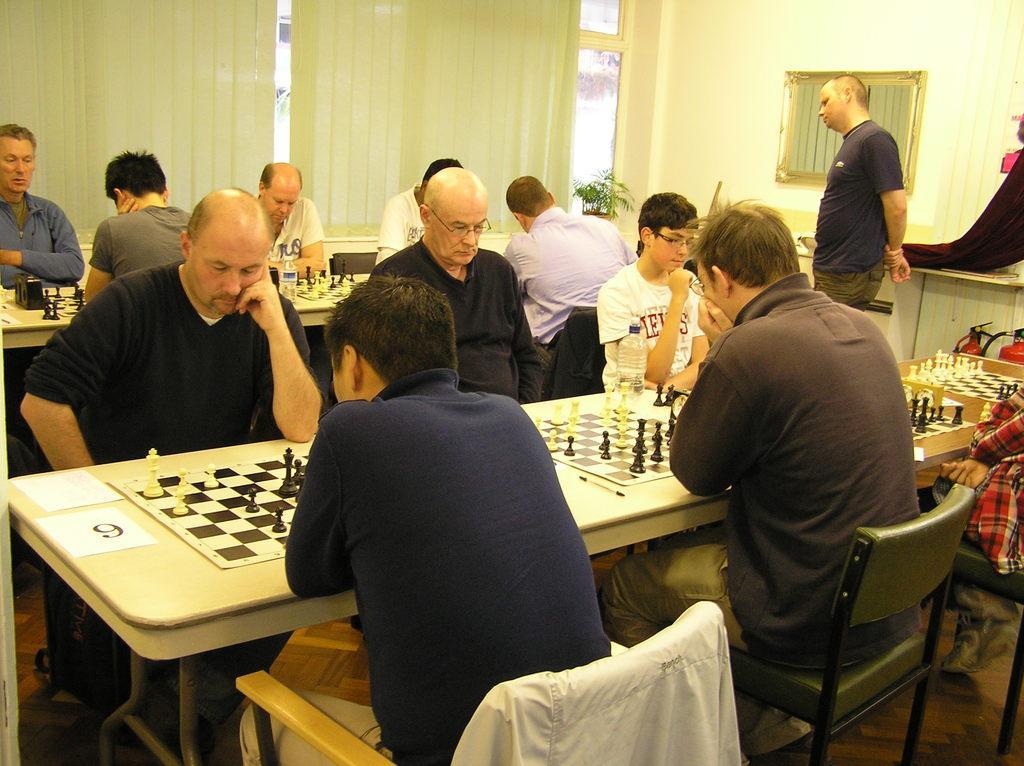Could you give a brief overview of what you see in this image? This picture shows a group of people seated on the chairs and playing chess on the table and we see a mirror on the wall and a man standing and watching them 